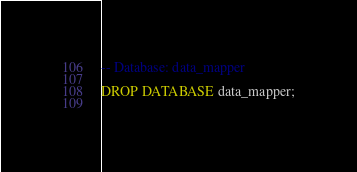Convert code to text. <code><loc_0><loc_0><loc_500><loc_500><_SQL_>-- Database: data_mapper

DROP DATABASE data_mapper;
  </code> 